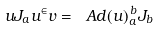<formula> <loc_0><loc_0><loc_500><loc_500>u J _ { a } u ^ { \in } v = \ A d ( u ) _ { a } ^ { \, b } J _ { b }</formula> 